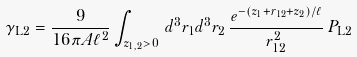<formula> <loc_0><loc_0><loc_500><loc_500>\gamma _ { \mathrm L 2 } = \frac { 9 } { 1 6 \pi A \ell ^ { 2 } } \int _ { z _ { 1 , 2 } > 0 } \, d ^ { 3 } { r } _ { 1 } d ^ { 3 } { r } _ { 2 } \, \frac { e ^ { - ( z _ { 1 } + r _ { 1 2 } + z _ { 2 } ) / \ell } } { r _ { 1 2 } ^ { 2 } } \, P _ { \mathrm L 2 }</formula> 